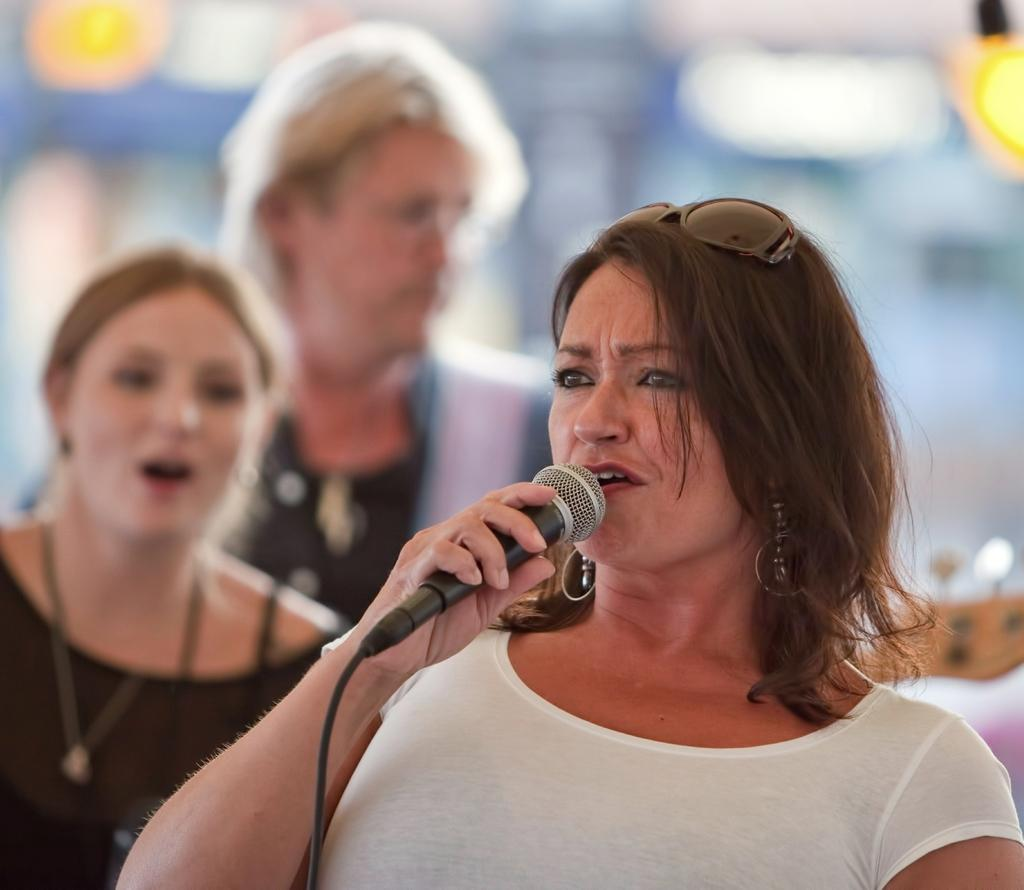What is the woman in the image holding? The woman is holding a mic in the image. What is the woman doing with the mic? The woman is talking while holding the mic. Can you describe the background of the image? There are two other women and lights visible in the background of the image. How would you describe the quality of the image? The image is blurry. What type of glove is the woman wearing in the image? There is no glove visible in the image; the woman is holding a mic and talking. 